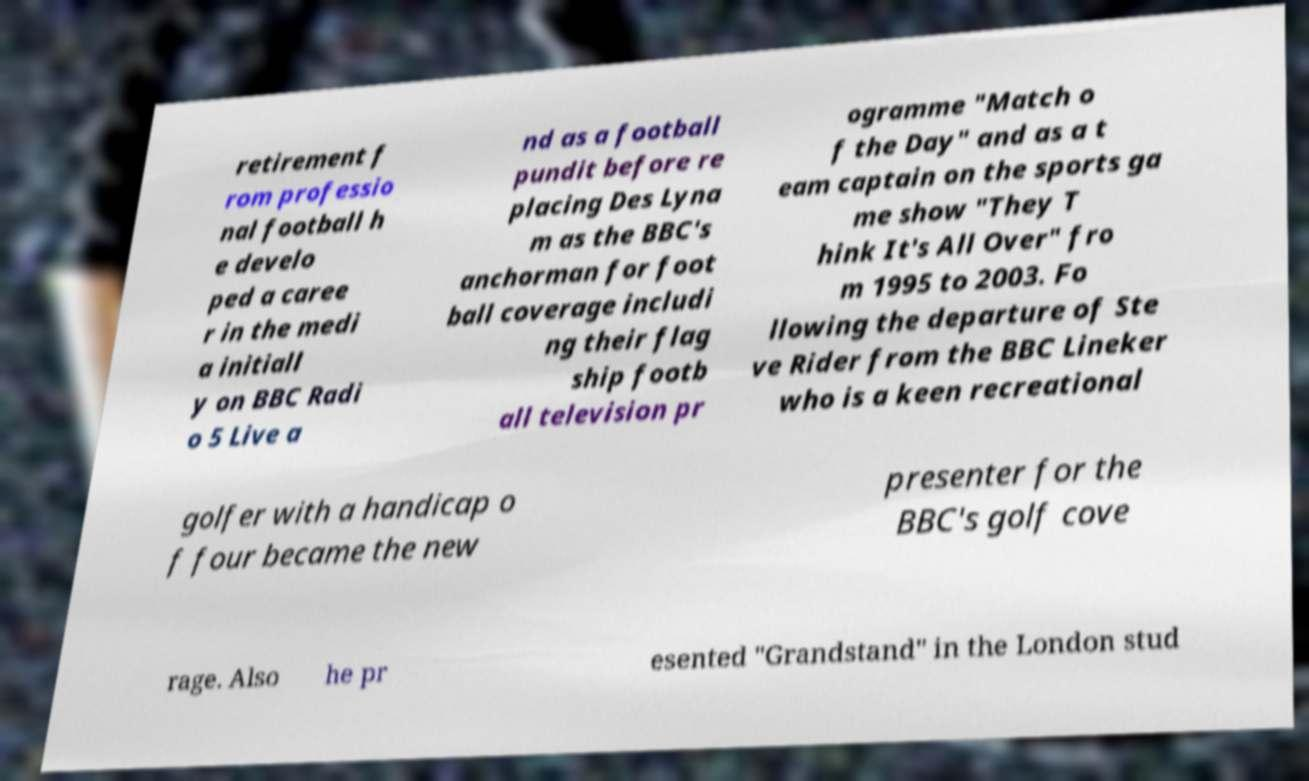There's text embedded in this image that I need extracted. Can you transcribe it verbatim? retirement f rom professio nal football h e develo ped a caree r in the medi a initiall y on BBC Radi o 5 Live a nd as a football pundit before re placing Des Lyna m as the BBC's anchorman for foot ball coverage includi ng their flag ship footb all television pr ogramme "Match o f the Day" and as a t eam captain on the sports ga me show "They T hink It's All Over" fro m 1995 to 2003. Fo llowing the departure of Ste ve Rider from the BBC Lineker who is a keen recreational golfer with a handicap o f four became the new presenter for the BBC's golf cove rage. Also he pr esented "Grandstand" in the London stud 